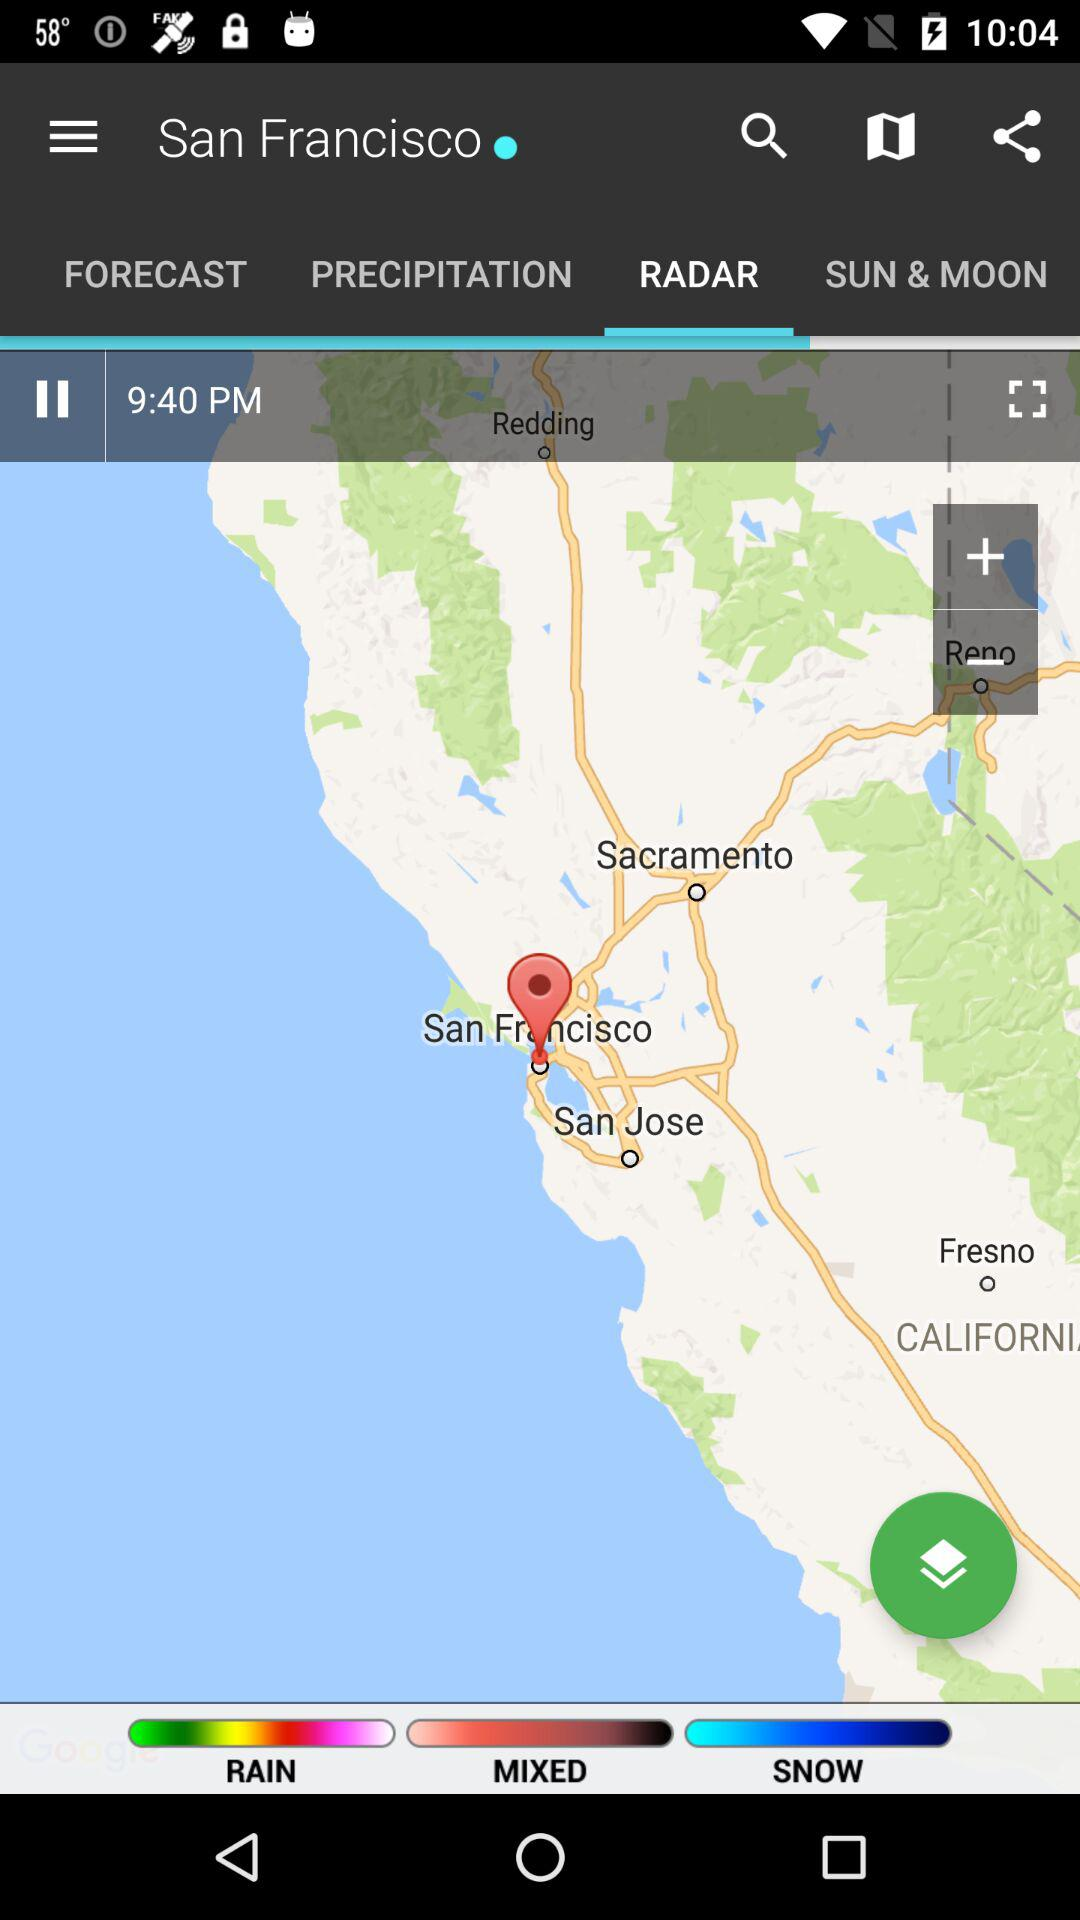Which tab is selected? The selected tab is "RADAR". 